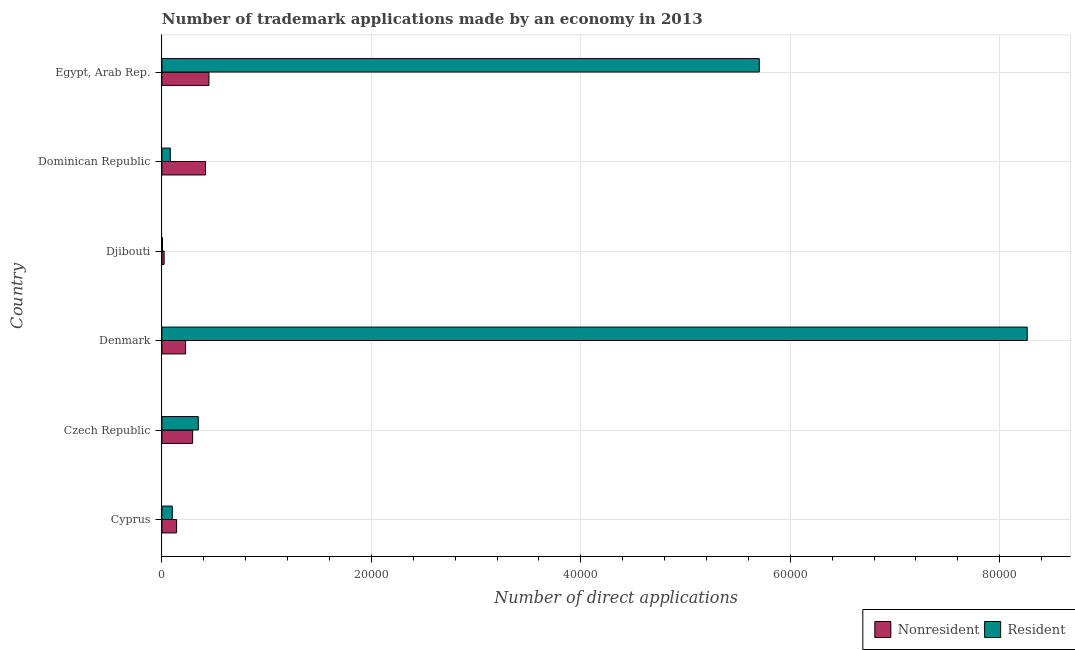How many different coloured bars are there?
Make the answer very short. 2. How many groups of bars are there?
Your answer should be very brief. 6. Are the number of bars on each tick of the Y-axis equal?
Offer a very short reply. Yes. How many bars are there on the 6th tick from the top?
Make the answer very short. 2. How many bars are there on the 2nd tick from the bottom?
Provide a short and direct response. 2. What is the label of the 2nd group of bars from the top?
Provide a short and direct response. Dominican Republic. What is the number of trademark applications made by residents in Czech Republic?
Keep it short and to the point. 3477. Across all countries, what is the maximum number of trademark applications made by residents?
Your response must be concise. 8.26e+04. Across all countries, what is the minimum number of trademark applications made by non residents?
Keep it short and to the point. 213. In which country was the number of trademark applications made by residents minimum?
Keep it short and to the point. Djibouti. What is the total number of trademark applications made by non residents in the graph?
Provide a succinct answer. 1.55e+04. What is the difference between the number of trademark applications made by residents in Cyprus and that in Denmark?
Make the answer very short. -8.16e+04. What is the difference between the number of trademark applications made by residents in Cyprus and the number of trademark applications made by non residents in Denmark?
Your answer should be compact. -1269. What is the average number of trademark applications made by non residents per country?
Ensure brevity in your answer.  2578.17. What is the difference between the number of trademark applications made by non residents and number of trademark applications made by residents in Cyprus?
Provide a short and direct response. 411. What is the ratio of the number of trademark applications made by non residents in Cyprus to that in Denmark?
Keep it short and to the point. 0.62. Is the difference between the number of trademark applications made by residents in Dominican Republic and Egypt, Arab Rep. greater than the difference between the number of trademark applications made by non residents in Dominican Republic and Egypt, Arab Rep.?
Make the answer very short. No. What is the difference between the highest and the second highest number of trademark applications made by residents?
Offer a terse response. 2.56e+04. What is the difference between the highest and the lowest number of trademark applications made by non residents?
Your answer should be compact. 4279. Is the sum of the number of trademark applications made by non residents in Djibouti and Dominican Republic greater than the maximum number of trademark applications made by residents across all countries?
Your answer should be compact. No. What does the 2nd bar from the top in Egypt, Arab Rep. represents?
Give a very brief answer. Nonresident. What does the 1st bar from the bottom in Djibouti represents?
Offer a very short reply. Nonresident. How many bars are there?
Your answer should be very brief. 12. How many countries are there in the graph?
Ensure brevity in your answer.  6. What is the difference between two consecutive major ticks on the X-axis?
Give a very brief answer. 2.00e+04. Are the values on the major ticks of X-axis written in scientific E-notation?
Offer a terse response. No. How many legend labels are there?
Provide a succinct answer. 2. How are the legend labels stacked?
Your answer should be very brief. Horizontal. What is the title of the graph?
Make the answer very short. Number of trademark applications made by an economy in 2013. What is the label or title of the X-axis?
Offer a very short reply. Number of direct applications. What is the Number of direct applications in Nonresident in Cyprus?
Make the answer very short. 1403. What is the Number of direct applications of Resident in Cyprus?
Offer a terse response. 992. What is the Number of direct applications of Nonresident in Czech Republic?
Offer a terse response. 2935. What is the Number of direct applications of Resident in Czech Republic?
Your answer should be compact. 3477. What is the Number of direct applications of Nonresident in Denmark?
Offer a terse response. 2261. What is the Number of direct applications of Resident in Denmark?
Keep it short and to the point. 8.26e+04. What is the Number of direct applications in Nonresident in Djibouti?
Keep it short and to the point. 213. What is the Number of direct applications in Resident in Djibouti?
Your answer should be compact. 56. What is the Number of direct applications of Nonresident in Dominican Republic?
Your response must be concise. 4165. What is the Number of direct applications of Resident in Dominican Republic?
Keep it short and to the point. 805. What is the Number of direct applications in Nonresident in Egypt, Arab Rep.?
Keep it short and to the point. 4492. What is the Number of direct applications of Resident in Egypt, Arab Rep.?
Give a very brief answer. 5.70e+04. Across all countries, what is the maximum Number of direct applications in Nonresident?
Provide a short and direct response. 4492. Across all countries, what is the maximum Number of direct applications of Resident?
Make the answer very short. 8.26e+04. Across all countries, what is the minimum Number of direct applications of Nonresident?
Provide a succinct answer. 213. What is the total Number of direct applications of Nonresident in the graph?
Ensure brevity in your answer.  1.55e+04. What is the total Number of direct applications in Resident in the graph?
Your answer should be compact. 1.45e+05. What is the difference between the Number of direct applications in Nonresident in Cyprus and that in Czech Republic?
Provide a short and direct response. -1532. What is the difference between the Number of direct applications in Resident in Cyprus and that in Czech Republic?
Ensure brevity in your answer.  -2485. What is the difference between the Number of direct applications in Nonresident in Cyprus and that in Denmark?
Keep it short and to the point. -858. What is the difference between the Number of direct applications in Resident in Cyprus and that in Denmark?
Offer a very short reply. -8.16e+04. What is the difference between the Number of direct applications of Nonresident in Cyprus and that in Djibouti?
Offer a terse response. 1190. What is the difference between the Number of direct applications of Resident in Cyprus and that in Djibouti?
Offer a very short reply. 936. What is the difference between the Number of direct applications of Nonresident in Cyprus and that in Dominican Republic?
Your response must be concise. -2762. What is the difference between the Number of direct applications of Resident in Cyprus and that in Dominican Republic?
Your response must be concise. 187. What is the difference between the Number of direct applications in Nonresident in Cyprus and that in Egypt, Arab Rep.?
Keep it short and to the point. -3089. What is the difference between the Number of direct applications in Resident in Cyprus and that in Egypt, Arab Rep.?
Keep it short and to the point. -5.60e+04. What is the difference between the Number of direct applications in Nonresident in Czech Republic and that in Denmark?
Offer a very short reply. 674. What is the difference between the Number of direct applications in Resident in Czech Republic and that in Denmark?
Your answer should be very brief. -7.91e+04. What is the difference between the Number of direct applications of Nonresident in Czech Republic and that in Djibouti?
Offer a terse response. 2722. What is the difference between the Number of direct applications in Resident in Czech Republic and that in Djibouti?
Offer a terse response. 3421. What is the difference between the Number of direct applications in Nonresident in Czech Republic and that in Dominican Republic?
Provide a short and direct response. -1230. What is the difference between the Number of direct applications in Resident in Czech Republic and that in Dominican Republic?
Offer a very short reply. 2672. What is the difference between the Number of direct applications of Nonresident in Czech Republic and that in Egypt, Arab Rep.?
Offer a very short reply. -1557. What is the difference between the Number of direct applications of Resident in Czech Republic and that in Egypt, Arab Rep.?
Your answer should be compact. -5.36e+04. What is the difference between the Number of direct applications in Nonresident in Denmark and that in Djibouti?
Keep it short and to the point. 2048. What is the difference between the Number of direct applications of Resident in Denmark and that in Djibouti?
Ensure brevity in your answer.  8.26e+04. What is the difference between the Number of direct applications in Nonresident in Denmark and that in Dominican Republic?
Make the answer very short. -1904. What is the difference between the Number of direct applications of Resident in Denmark and that in Dominican Republic?
Offer a very short reply. 8.18e+04. What is the difference between the Number of direct applications in Nonresident in Denmark and that in Egypt, Arab Rep.?
Give a very brief answer. -2231. What is the difference between the Number of direct applications of Resident in Denmark and that in Egypt, Arab Rep.?
Your answer should be compact. 2.56e+04. What is the difference between the Number of direct applications of Nonresident in Djibouti and that in Dominican Republic?
Your response must be concise. -3952. What is the difference between the Number of direct applications in Resident in Djibouti and that in Dominican Republic?
Offer a terse response. -749. What is the difference between the Number of direct applications of Nonresident in Djibouti and that in Egypt, Arab Rep.?
Keep it short and to the point. -4279. What is the difference between the Number of direct applications of Resident in Djibouti and that in Egypt, Arab Rep.?
Provide a succinct answer. -5.70e+04. What is the difference between the Number of direct applications in Nonresident in Dominican Republic and that in Egypt, Arab Rep.?
Offer a very short reply. -327. What is the difference between the Number of direct applications in Resident in Dominican Republic and that in Egypt, Arab Rep.?
Offer a very short reply. -5.62e+04. What is the difference between the Number of direct applications of Nonresident in Cyprus and the Number of direct applications of Resident in Czech Republic?
Your answer should be very brief. -2074. What is the difference between the Number of direct applications of Nonresident in Cyprus and the Number of direct applications of Resident in Denmark?
Offer a terse response. -8.12e+04. What is the difference between the Number of direct applications in Nonresident in Cyprus and the Number of direct applications in Resident in Djibouti?
Ensure brevity in your answer.  1347. What is the difference between the Number of direct applications of Nonresident in Cyprus and the Number of direct applications of Resident in Dominican Republic?
Offer a very short reply. 598. What is the difference between the Number of direct applications in Nonresident in Cyprus and the Number of direct applications in Resident in Egypt, Arab Rep.?
Your answer should be compact. -5.56e+04. What is the difference between the Number of direct applications of Nonresident in Czech Republic and the Number of direct applications of Resident in Denmark?
Give a very brief answer. -7.97e+04. What is the difference between the Number of direct applications of Nonresident in Czech Republic and the Number of direct applications of Resident in Djibouti?
Keep it short and to the point. 2879. What is the difference between the Number of direct applications in Nonresident in Czech Republic and the Number of direct applications in Resident in Dominican Republic?
Provide a succinct answer. 2130. What is the difference between the Number of direct applications of Nonresident in Czech Republic and the Number of direct applications of Resident in Egypt, Arab Rep.?
Your answer should be compact. -5.41e+04. What is the difference between the Number of direct applications of Nonresident in Denmark and the Number of direct applications of Resident in Djibouti?
Offer a terse response. 2205. What is the difference between the Number of direct applications of Nonresident in Denmark and the Number of direct applications of Resident in Dominican Republic?
Ensure brevity in your answer.  1456. What is the difference between the Number of direct applications of Nonresident in Denmark and the Number of direct applications of Resident in Egypt, Arab Rep.?
Provide a short and direct response. -5.48e+04. What is the difference between the Number of direct applications in Nonresident in Djibouti and the Number of direct applications in Resident in Dominican Republic?
Your response must be concise. -592. What is the difference between the Number of direct applications in Nonresident in Djibouti and the Number of direct applications in Resident in Egypt, Arab Rep.?
Provide a short and direct response. -5.68e+04. What is the difference between the Number of direct applications of Nonresident in Dominican Republic and the Number of direct applications of Resident in Egypt, Arab Rep.?
Your response must be concise. -5.29e+04. What is the average Number of direct applications in Nonresident per country?
Give a very brief answer. 2578.17. What is the average Number of direct applications of Resident per country?
Offer a very short reply. 2.42e+04. What is the difference between the Number of direct applications in Nonresident and Number of direct applications in Resident in Cyprus?
Offer a terse response. 411. What is the difference between the Number of direct applications of Nonresident and Number of direct applications of Resident in Czech Republic?
Give a very brief answer. -542. What is the difference between the Number of direct applications in Nonresident and Number of direct applications in Resident in Denmark?
Your answer should be compact. -8.04e+04. What is the difference between the Number of direct applications of Nonresident and Number of direct applications of Resident in Djibouti?
Provide a short and direct response. 157. What is the difference between the Number of direct applications in Nonresident and Number of direct applications in Resident in Dominican Republic?
Offer a very short reply. 3360. What is the difference between the Number of direct applications in Nonresident and Number of direct applications in Resident in Egypt, Arab Rep.?
Offer a terse response. -5.25e+04. What is the ratio of the Number of direct applications in Nonresident in Cyprus to that in Czech Republic?
Your answer should be very brief. 0.48. What is the ratio of the Number of direct applications in Resident in Cyprus to that in Czech Republic?
Provide a short and direct response. 0.29. What is the ratio of the Number of direct applications of Nonresident in Cyprus to that in Denmark?
Your response must be concise. 0.62. What is the ratio of the Number of direct applications of Resident in Cyprus to that in Denmark?
Provide a succinct answer. 0.01. What is the ratio of the Number of direct applications in Nonresident in Cyprus to that in Djibouti?
Your response must be concise. 6.59. What is the ratio of the Number of direct applications of Resident in Cyprus to that in Djibouti?
Give a very brief answer. 17.71. What is the ratio of the Number of direct applications in Nonresident in Cyprus to that in Dominican Republic?
Provide a succinct answer. 0.34. What is the ratio of the Number of direct applications of Resident in Cyprus to that in Dominican Republic?
Offer a very short reply. 1.23. What is the ratio of the Number of direct applications of Nonresident in Cyprus to that in Egypt, Arab Rep.?
Provide a succinct answer. 0.31. What is the ratio of the Number of direct applications in Resident in Cyprus to that in Egypt, Arab Rep.?
Give a very brief answer. 0.02. What is the ratio of the Number of direct applications in Nonresident in Czech Republic to that in Denmark?
Give a very brief answer. 1.3. What is the ratio of the Number of direct applications in Resident in Czech Republic to that in Denmark?
Offer a terse response. 0.04. What is the ratio of the Number of direct applications in Nonresident in Czech Republic to that in Djibouti?
Provide a short and direct response. 13.78. What is the ratio of the Number of direct applications of Resident in Czech Republic to that in Djibouti?
Ensure brevity in your answer.  62.09. What is the ratio of the Number of direct applications in Nonresident in Czech Republic to that in Dominican Republic?
Keep it short and to the point. 0.7. What is the ratio of the Number of direct applications in Resident in Czech Republic to that in Dominican Republic?
Offer a very short reply. 4.32. What is the ratio of the Number of direct applications in Nonresident in Czech Republic to that in Egypt, Arab Rep.?
Your answer should be compact. 0.65. What is the ratio of the Number of direct applications of Resident in Czech Republic to that in Egypt, Arab Rep.?
Keep it short and to the point. 0.06. What is the ratio of the Number of direct applications of Nonresident in Denmark to that in Djibouti?
Your answer should be compact. 10.62. What is the ratio of the Number of direct applications in Resident in Denmark to that in Djibouti?
Provide a short and direct response. 1475.46. What is the ratio of the Number of direct applications of Nonresident in Denmark to that in Dominican Republic?
Provide a short and direct response. 0.54. What is the ratio of the Number of direct applications of Resident in Denmark to that in Dominican Republic?
Make the answer very short. 102.64. What is the ratio of the Number of direct applications in Nonresident in Denmark to that in Egypt, Arab Rep.?
Provide a succinct answer. 0.5. What is the ratio of the Number of direct applications in Resident in Denmark to that in Egypt, Arab Rep.?
Give a very brief answer. 1.45. What is the ratio of the Number of direct applications in Nonresident in Djibouti to that in Dominican Republic?
Provide a succinct answer. 0.05. What is the ratio of the Number of direct applications in Resident in Djibouti to that in Dominican Republic?
Offer a terse response. 0.07. What is the ratio of the Number of direct applications in Nonresident in Djibouti to that in Egypt, Arab Rep.?
Make the answer very short. 0.05. What is the ratio of the Number of direct applications in Nonresident in Dominican Republic to that in Egypt, Arab Rep.?
Your answer should be very brief. 0.93. What is the ratio of the Number of direct applications in Resident in Dominican Republic to that in Egypt, Arab Rep.?
Keep it short and to the point. 0.01. What is the difference between the highest and the second highest Number of direct applications in Nonresident?
Your response must be concise. 327. What is the difference between the highest and the second highest Number of direct applications of Resident?
Offer a terse response. 2.56e+04. What is the difference between the highest and the lowest Number of direct applications in Nonresident?
Your response must be concise. 4279. What is the difference between the highest and the lowest Number of direct applications of Resident?
Offer a terse response. 8.26e+04. 